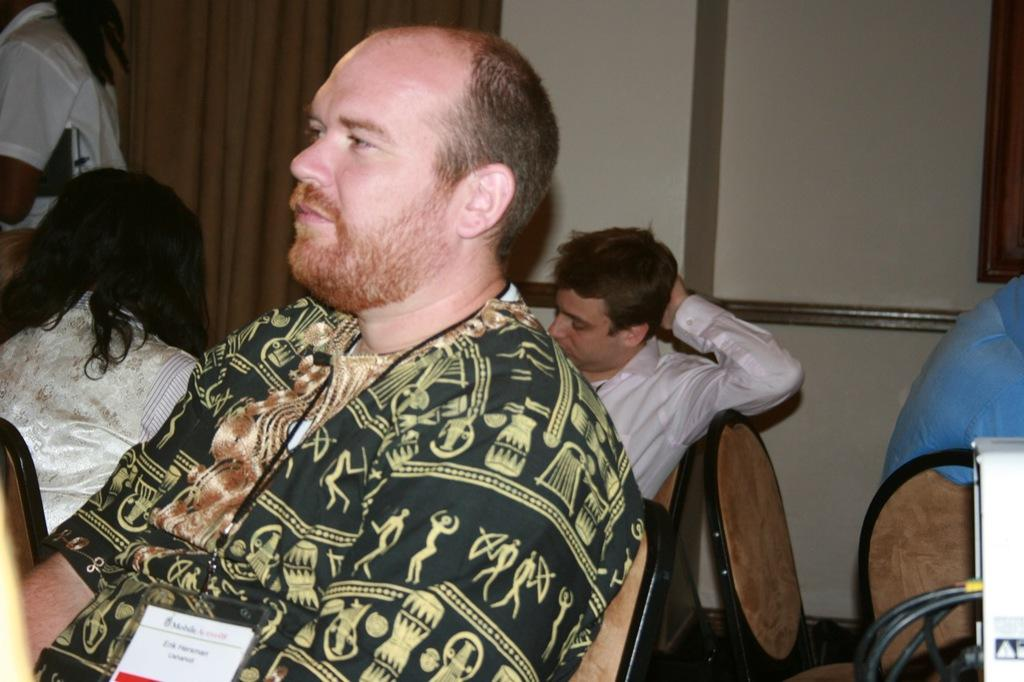What is the main subject in the foreground of the picture? There is a person sitting in the foreground of the picture. What can be seen behind the person? There are chairs and people behind the person. Can you describe the people on the left side of the image? There are two women on the left side of the image. What is visible in the background of the image? There is a curtain and a wall in the background of the image. What type of ship can be seen sailing on the side of the image? There is no ship present in the image; it features a person sitting, chairs and people behind them, two women on the left side, and a curtain and wall in the background. Is there an umbrella visible in the image? No, there is no umbrella present in the image. 